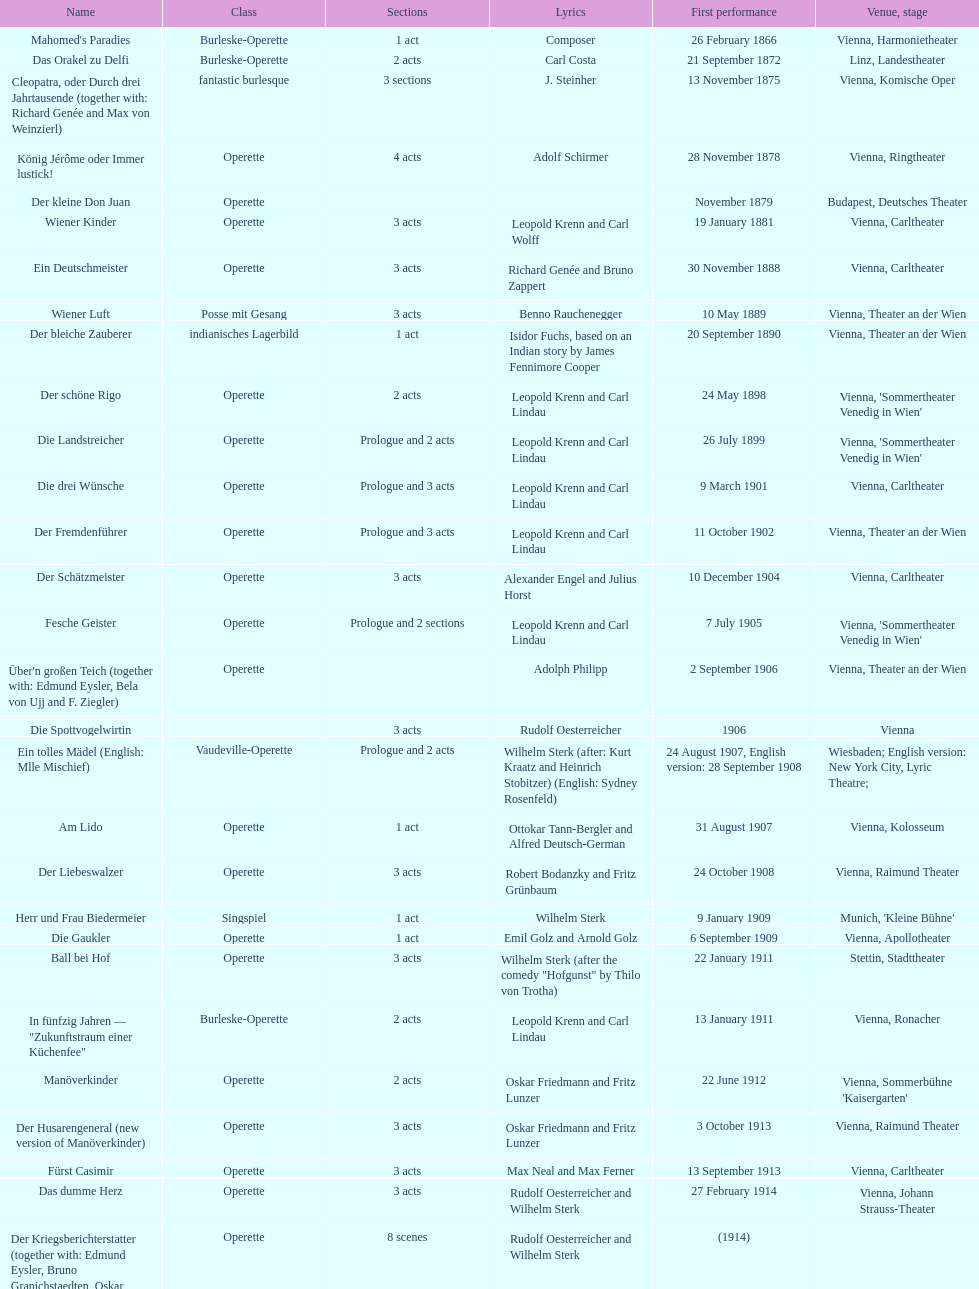In which city did the most operettas premiere? Vienna. 